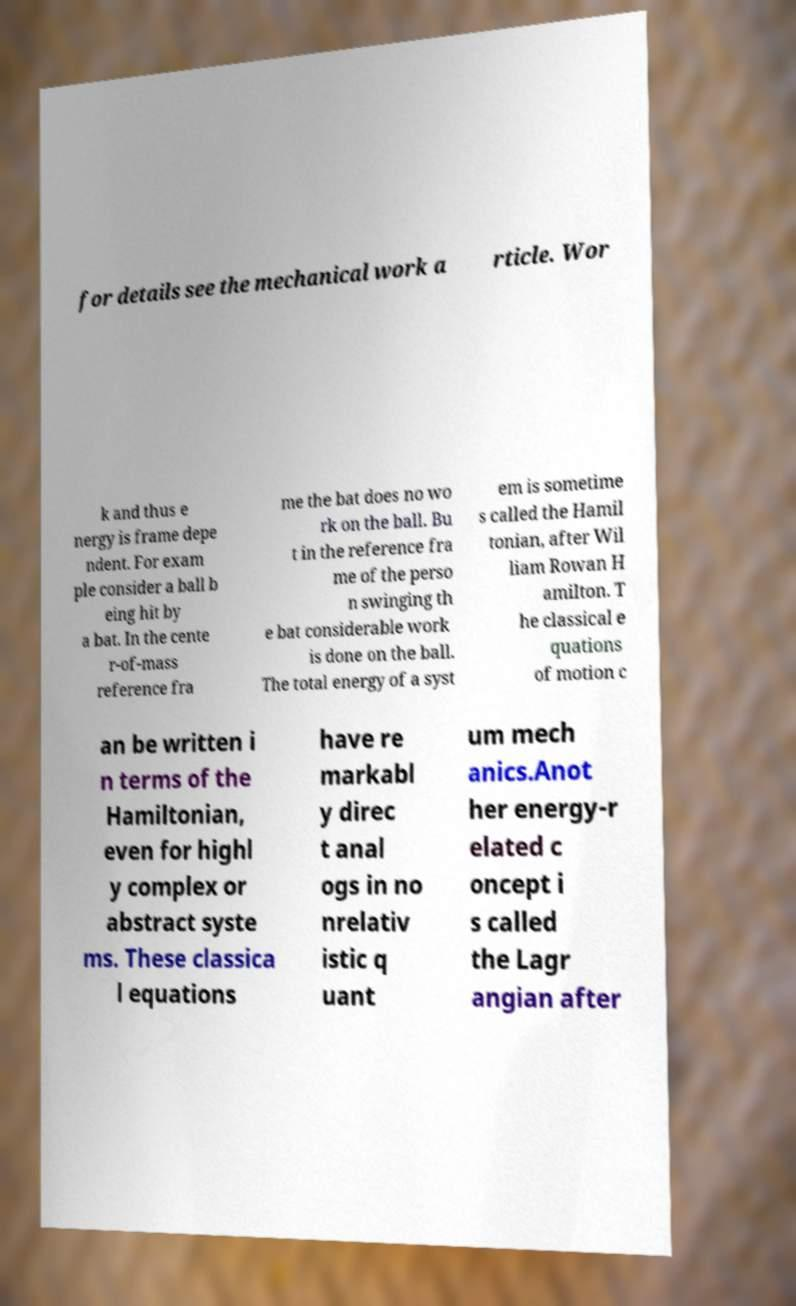Please identify and transcribe the text found in this image. for details see the mechanical work a rticle. Wor k and thus e nergy is frame depe ndent. For exam ple consider a ball b eing hit by a bat. In the cente r-of-mass reference fra me the bat does no wo rk on the ball. Bu t in the reference fra me of the perso n swinging th e bat considerable work is done on the ball. The total energy of a syst em is sometime s called the Hamil tonian, after Wil liam Rowan H amilton. T he classical e quations of motion c an be written i n terms of the Hamiltonian, even for highl y complex or abstract syste ms. These classica l equations have re markabl y direc t anal ogs in no nrelativ istic q uant um mech anics.Anot her energy-r elated c oncept i s called the Lagr angian after 